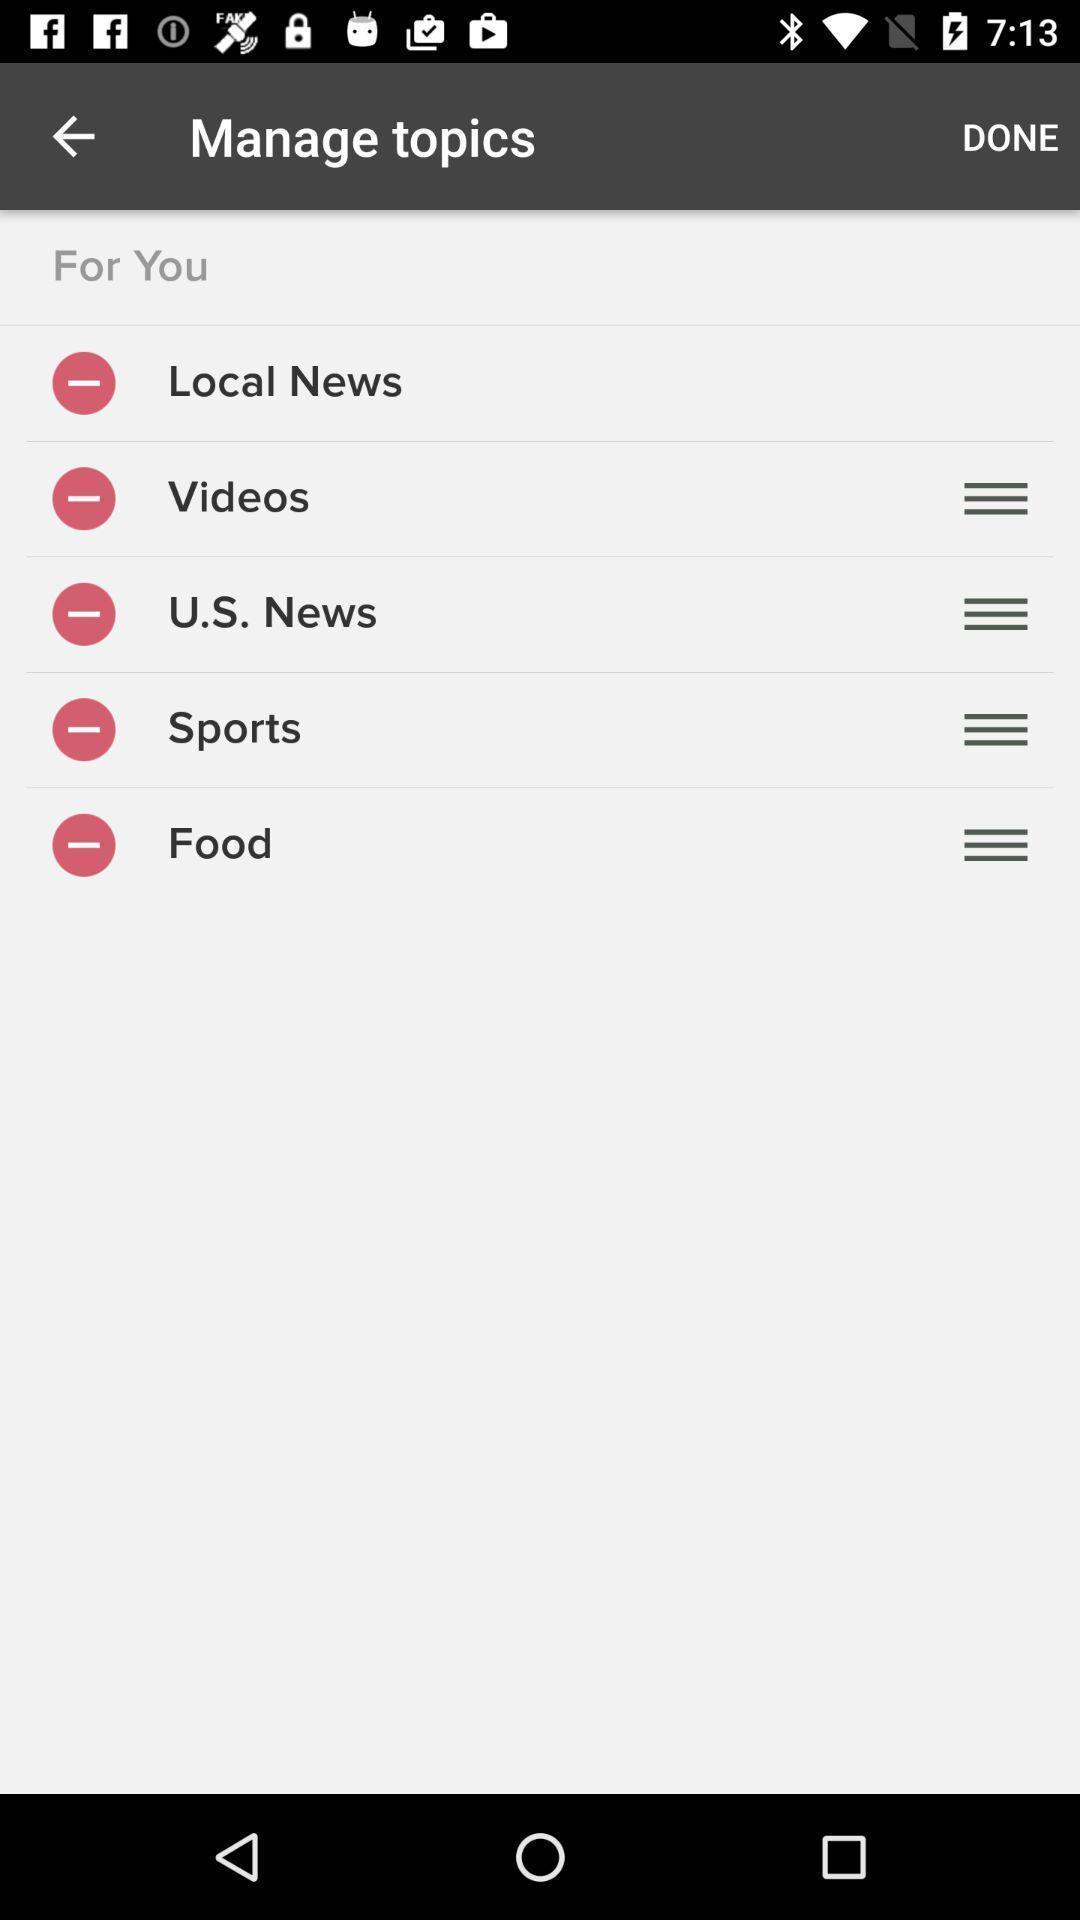Tell me what you see in this picture. Screen shows list of manage topics in a news app. 